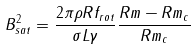Convert formula to latex. <formula><loc_0><loc_0><loc_500><loc_500>B _ { s a t } ^ { 2 } = \frac { 2 \pi \rho R f _ { r o t } } { \sigma L \gamma } \frac { R m - R m _ { c } } { R m _ { c } }</formula> 